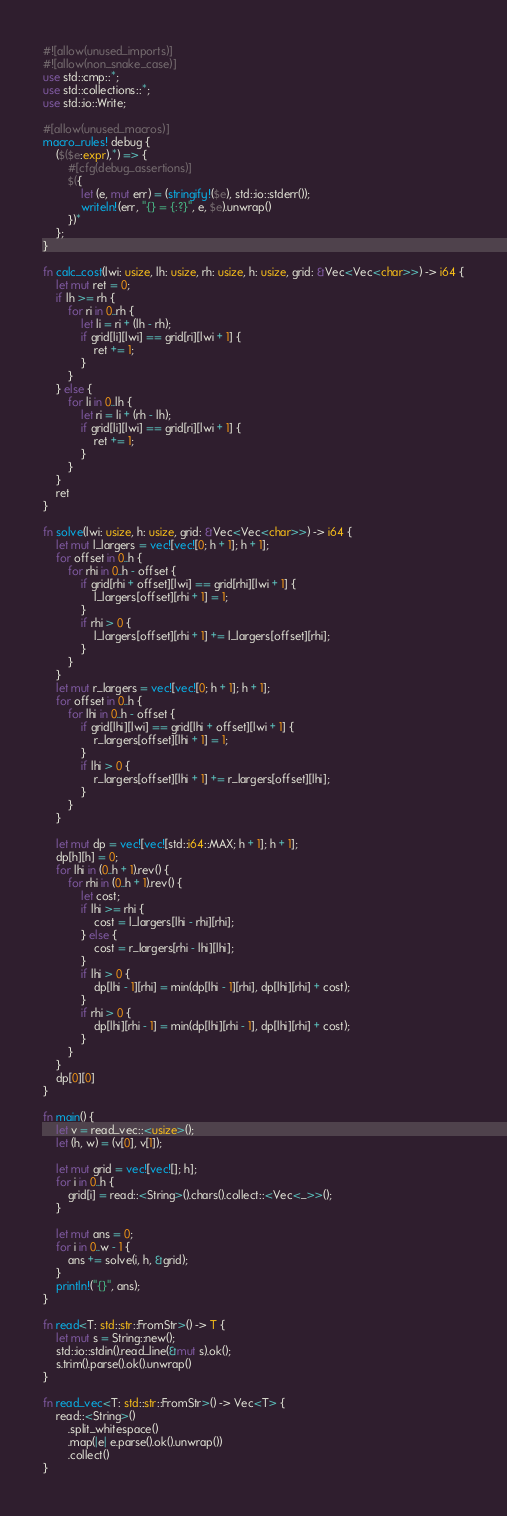Convert code to text. <code><loc_0><loc_0><loc_500><loc_500><_Rust_>#![allow(unused_imports)]
#![allow(non_snake_case)]
use std::cmp::*;
use std::collections::*;
use std::io::Write;

#[allow(unused_macros)]
macro_rules! debug {
    ($($e:expr),*) => {
        #[cfg(debug_assertions)]
        $({
            let (e, mut err) = (stringify!($e), std::io::stderr());
            writeln!(err, "{} = {:?}", e, $e).unwrap()
        })*
    };
}

fn calc_cost(lwi: usize, lh: usize, rh: usize, h: usize, grid: &Vec<Vec<char>>) -> i64 {
    let mut ret = 0;
    if lh >= rh {
        for ri in 0..rh {
            let li = ri + (lh - rh);
            if grid[li][lwi] == grid[ri][lwi + 1] {
                ret += 1;
            }
        }
    } else {
        for li in 0..lh {
            let ri = li + (rh - lh);
            if grid[li][lwi] == grid[ri][lwi + 1] {
                ret += 1;
            }
        }
    }
    ret
}

fn solve(lwi: usize, h: usize, grid: &Vec<Vec<char>>) -> i64 {
    let mut l_largers = vec![vec![0; h + 1]; h + 1];
    for offset in 0..h {
        for rhi in 0..h - offset {
            if grid[rhi + offset][lwi] == grid[rhi][lwi + 1] {
                l_largers[offset][rhi + 1] = 1;
            }
            if rhi > 0 {
                l_largers[offset][rhi + 1] += l_largers[offset][rhi];
            }
        }
    }
    let mut r_largers = vec![vec![0; h + 1]; h + 1];
    for offset in 0..h {
        for lhi in 0..h - offset {
            if grid[lhi][lwi] == grid[lhi + offset][lwi + 1] {
                r_largers[offset][lhi + 1] = 1;
            }
            if lhi > 0 {
                r_largers[offset][lhi + 1] += r_largers[offset][lhi];
            }
        }
    }

    let mut dp = vec![vec![std::i64::MAX; h + 1]; h + 1];
    dp[h][h] = 0;
    for lhi in (0..h + 1).rev() {
        for rhi in (0..h + 1).rev() {
            let cost;
            if lhi >= rhi {
                cost = l_largers[lhi - rhi][rhi];
            } else {
                cost = r_largers[rhi - lhi][lhi];
            }
            if lhi > 0 {
                dp[lhi - 1][rhi] = min(dp[lhi - 1][rhi], dp[lhi][rhi] + cost);
            }
            if rhi > 0 {
                dp[lhi][rhi - 1] = min(dp[lhi][rhi - 1], dp[lhi][rhi] + cost);
            }
        }
    }
    dp[0][0]
}

fn main() {
    let v = read_vec::<usize>();
    let (h, w) = (v[0], v[1]);

    let mut grid = vec![vec![]; h];
    for i in 0..h {
        grid[i] = read::<String>().chars().collect::<Vec<_>>();
    }

    let mut ans = 0;
    for i in 0..w - 1 {
        ans += solve(i, h, &grid);
    }
    println!("{}", ans);
}

fn read<T: std::str::FromStr>() -> T {
    let mut s = String::new();
    std::io::stdin().read_line(&mut s).ok();
    s.trim().parse().ok().unwrap()
}

fn read_vec<T: std::str::FromStr>() -> Vec<T> {
    read::<String>()
        .split_whitespace()
        .map(|e| e.parse().ok().unwrap())
        .collect()
}
</code> 